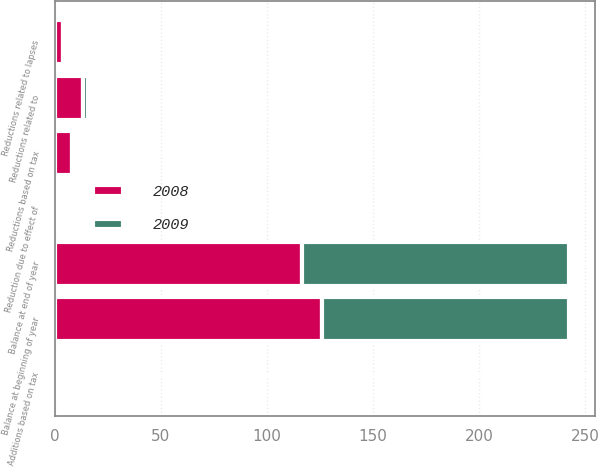Convert chart to OTSL. <chart><loc_0><loc_0><loc_500><loc_500><stacked_bar_chart><ecel><fcel>Balance at beginning of year<fcel>Additions based on tax<fcel>Reductions based on tax<fcel>Reductions related to<fcel>Reductions related to lapses<fcel>Reduction due to effect of<fcel>Balance at end of year<nl><fcel>2008<fcel>125.8<fcel>2.2<fcel>8.1<fcel>13.3<fcel>3.9<fcel>1.3<fcel>116.7<nl><fcel>2009<fcel>116.5<fcel>0.1<fcel>1.3<fcel>2.3<fcel>0.8<fcel>0.9<fcel>125.8<nl></chart> 